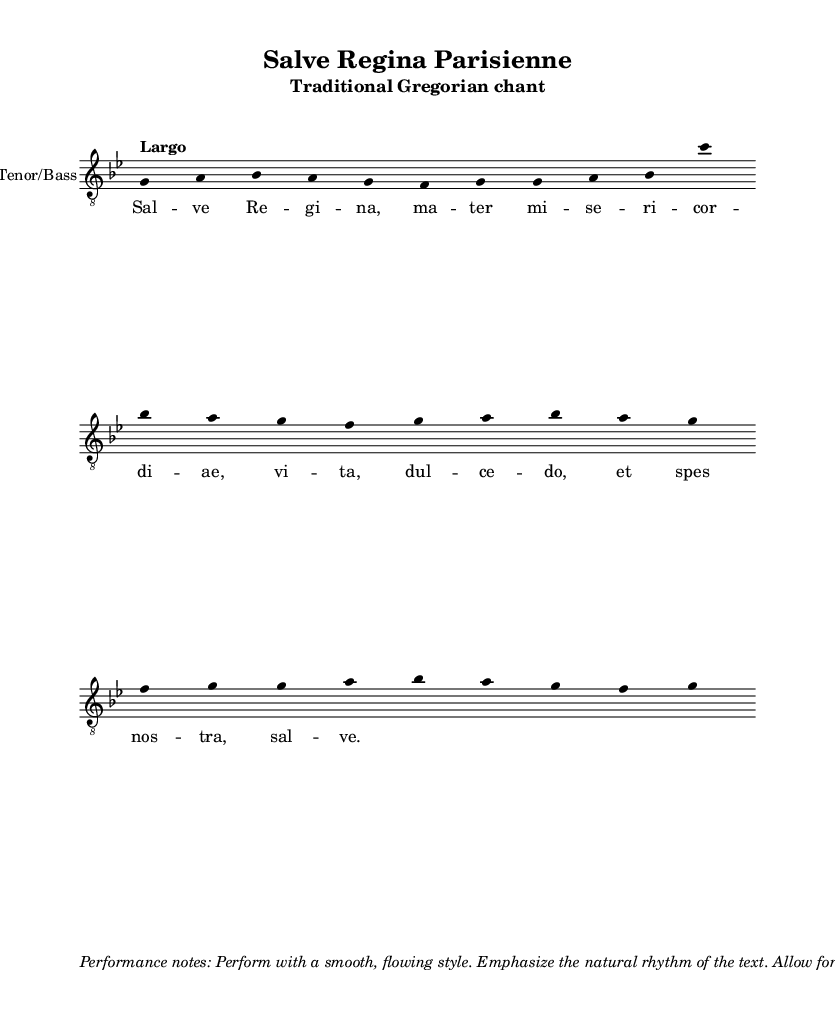What is the key signature of this music? The key signature is indicated by the presence of two flats in the music, which corresponds to the key of G minor.
Answer: G minor What is the tempo marking for this chant? The tempo marking is shown at the beginning of the music and indicates a slow pace, labeled as "Largo."
Answer: Largo How many measures are in the piece? By counting the bar lines in the music, we can see there are four distinct measures in the score.
Answer: Four What is the clef used in this piece? The clef is indicated in the staff; here it is specified as "treble_8," which means the notes are played one octave lower than written.
Answer: Treble_8 What is the title of this piece? The title is prominently displayed at the top of the sheet music, featuring "Salve Regina Parisienne" as the main title.
Answer: Salve Regina Parisienne What lyrical theme does this chant express? The lyrics suggest a theme of pleas for mercy, signified by terms such as "Salve Regina" and "mater misericordiae," which point towards a reverent addressing of the Virgin Mary.
Answer: Mercy What type of music is represented in this sheet? The sheet is categorized as a traditional Gregorian chant, which is characterized by its unaccompanied vocal music.
Answer: Gregorian chant 